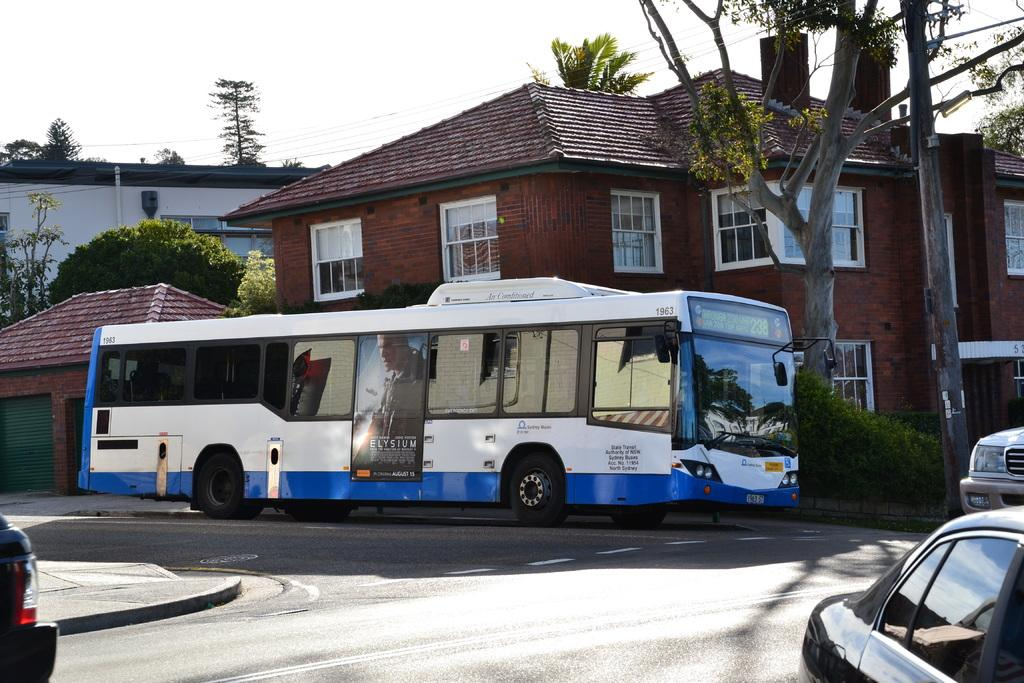What type of vehicle is the main subject of the image? There is a bus in the image. How many other vehicles are visible in the image? There are two cars in the image. Where are the vehicles located? The vehicles are on a road. What can be seen in the background of the image? There are many trees and buildings in the background of the image. What is attached to the bus? There is a poster attached to the bus. What is visible at the top of the image? The sky is visible at the top of the image. What is the brass instrument being played by the driver of the bus in the image? There is no brass instrument or driver playing an instrument in the image; it features a bus, cars, and a poster on the bus. 